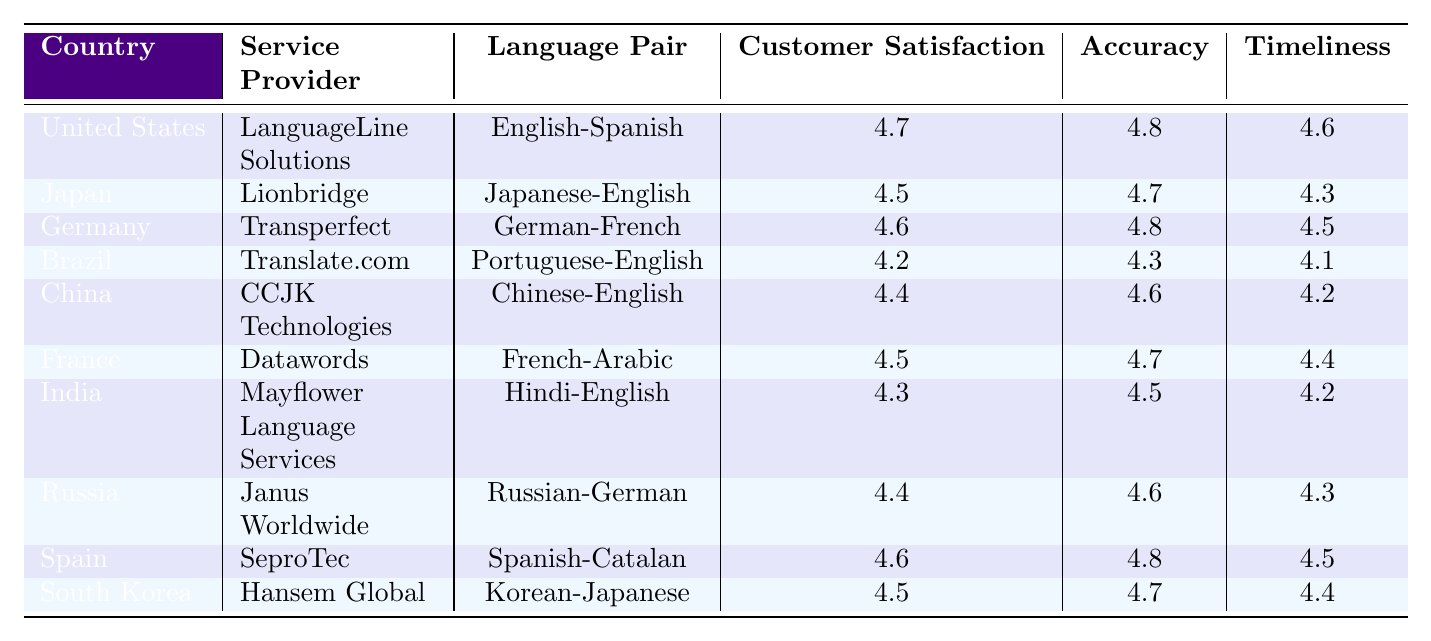What is the highest Customer Satisfaction Score among the countries listed? Looking at the table, the highest Customer Satisfaction Score is noted for the United States at 4.7.
Answer: 4.7 Which country has the lowest Timeliness Score? By scanning the Timeliness Scores, Brazil has the lowest score of 4.1.
Answer: 4.1 What is the average Accuracy Rating for the countries listed? To find the average Accuracy Rating, sum the values (4.8 + 4.7 + 4.8 + 4.3 + 4.6 + 4.7 + 4.5 + 4.6 + 4.8 + 4.7 = 47.7) and divide by the number of countries (10). Thus, the average is 47.7 / 10 = 4.77.
Answer: 4.77 Is the Customer Satisfaction Score for Spain higher than that of Brazil? Spain has a Customer Satisfaction Score of 4.6 while Brazil's is 4.2. Therefore, it is true that Spain's score is higher than Brazil's.
Answer: Yes Which service provider received the highest Accuracy Rating? The table reveals that LanguageLine Solutions achieves the highest Accuracy Rating of 4.8.
Answer: LanguageLine Solutions What is the difference between the Timeliness Score of Germany and that of South Korea? Germany's Timeliness Score is 4.5, and South Korea's is 4.4. Therefore, the difference is 4.5 - 4.4 = 0.1.
Answer: 0.1 Which two countries have the same Customer Satisfaction Score? India and China both have a Customer Satisfaction Score of 4.4. Thus, they are the two countries with the same score.
Answer: India and China If you average the Customer Satisfaction Scores from the table, what result do you get? Summing all the Customer Satisfaction Scores (4.7 + 4.5 + 4.6 + 4.2 + 4.4 + 4.5 + 4.3 + 4.4 + 4.6 + 4.5 = 44.7) and dividing by the number of entries (10) gives an average of 4.47.
Answer: 4.47 Are there more countries with scores above 4.5 or below 4.5 in Customer Satisfaction? By checking the Customer Satisfaction Scores, there are 6 countries scoring above 4.5 and 4 countries below. Therefore, there are more countries above 4.5.
Answer: Above 4.5 What is the Timeliness Score for the language pair English-Spanish? The Timeliness Score for the language pair English-Spanish is noted as 4.6 for the United States.
Answer: 4.6 